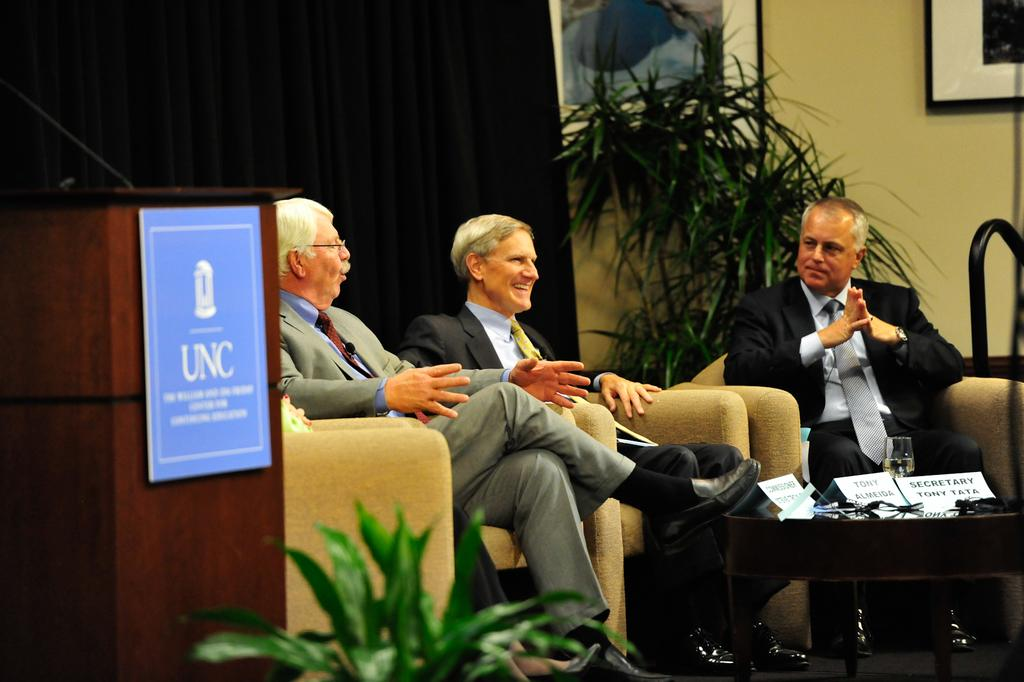How many people are sitting on the couch in the image? There are three men sitting on a couch in the image. What is located at the left side of the image? There is a podium at the left side of the image. What can be seen in the background of the image? There is a plant, a frame attached to a wall, and a curtain in the background of the image. What type of cemetery can be seen in the background of the image? There is no cemetery present in the background of the image; it features a plant, a frame attached to a wall, and a curtain. How many legs are visible in the image? The number of legs visible in the image cannot be determined from the provided facts, as they only mention the presence of three men sitting on a couch and a podium at the left side of the image. 